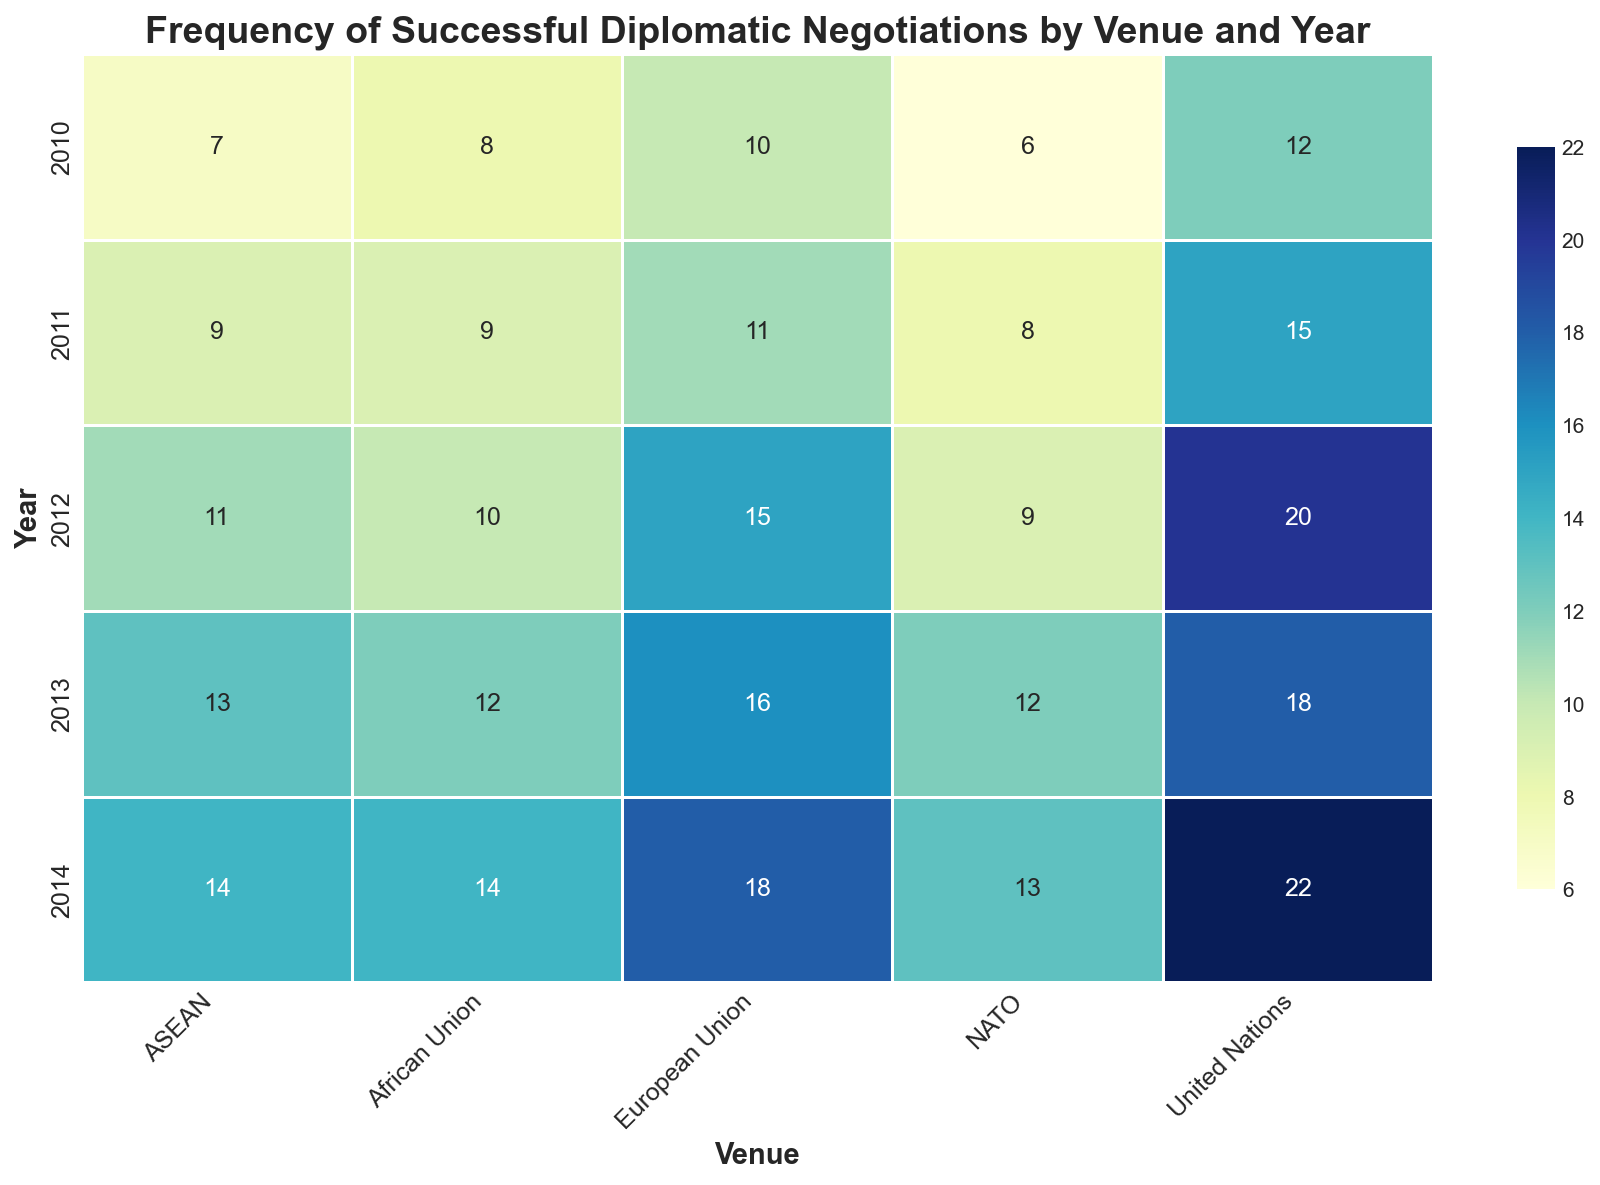Which venue had the highest number of successful diplomatic negotiations in 2014? First, look at the column for the year 2014, then check which cell in that column has the highest number. The United Nations has the highest number of successful negotiations with 22.
Answer: United Nations Which year saw the most successful negotiations at NATO? Check the numbers under the NATO column and find the highest value. The year with the most successful negotiations for NATO is 2014 with 13.
Answer: 2014 What was the total number of successful negotiations in 2011 across all venues? Summing the successful negotiations from all venues in 2011: United Nations (15) + European Union (11) + African Union (9) + ASEAN (9) + NATO (8). Therefore, 15 + 11 + 9 + 9 + 8 = 52.
Answer: 52 Compare the successful negotiations between the United Nations and ASEAN in 2013. Which had more and by how much? United Nations had 18 successful negotiations, ASEAN had 13 in 2013. Subtract ASEAN's total from the United Nations', 18 - 13 = 5. The United Nations had 5 more successful negotiations than ASEAN in 2013.
Answer: United Nations, by 5 By how much did the successful negotiations at the European Union increase from 2012 to 2014? The successful negotiations at the European Union in 2012 were 15, and in 2014 they were 18. The difference is 18 - 15 = 3.
Answer: 3 Which venue had the least number of successful negotiations in 2010, and what was the count? Look across the 2010 row and find the smallest number in that row. NATO had the least successful negotiations with 6 in 2010.
Answer: NATO, 6 What pattern can you infer from the successful negotiation trend at the African Union from 2010 to 2014? Observing the African Union column, the numbers are 8, 9, 10, 12, 14 from 2010 to 2014. The trend shows a consistent yearly increase.
Answer: A consistent increase What is the average number of successful negotiations for ASEAN between 2010 and 2014? Sum the successful negotiations for ASEAN: 7 + 9 + 11 + 13 + 14 = 54. There are 5 years, so the average is 54/5 = 10.8.
Answer: 10.8 In which year did the United Nations experience a dip in successful negotiations compared to the previous year? Comparing the numbers year by year for the United Nations, the successful negotiations drop from 20 in 2012 to 18 in 2013.
Answer: 2013 Which venue had a higher rate of increase in successful negotiations from 2010 to 2014, NATO or ASEAN? NATO increased from 6 to 13 (a total increase of 7), while ASEAN increased from 7 to 14 (a total increase of 7). Both increased by the same amount.
Answer: Both increased equally 